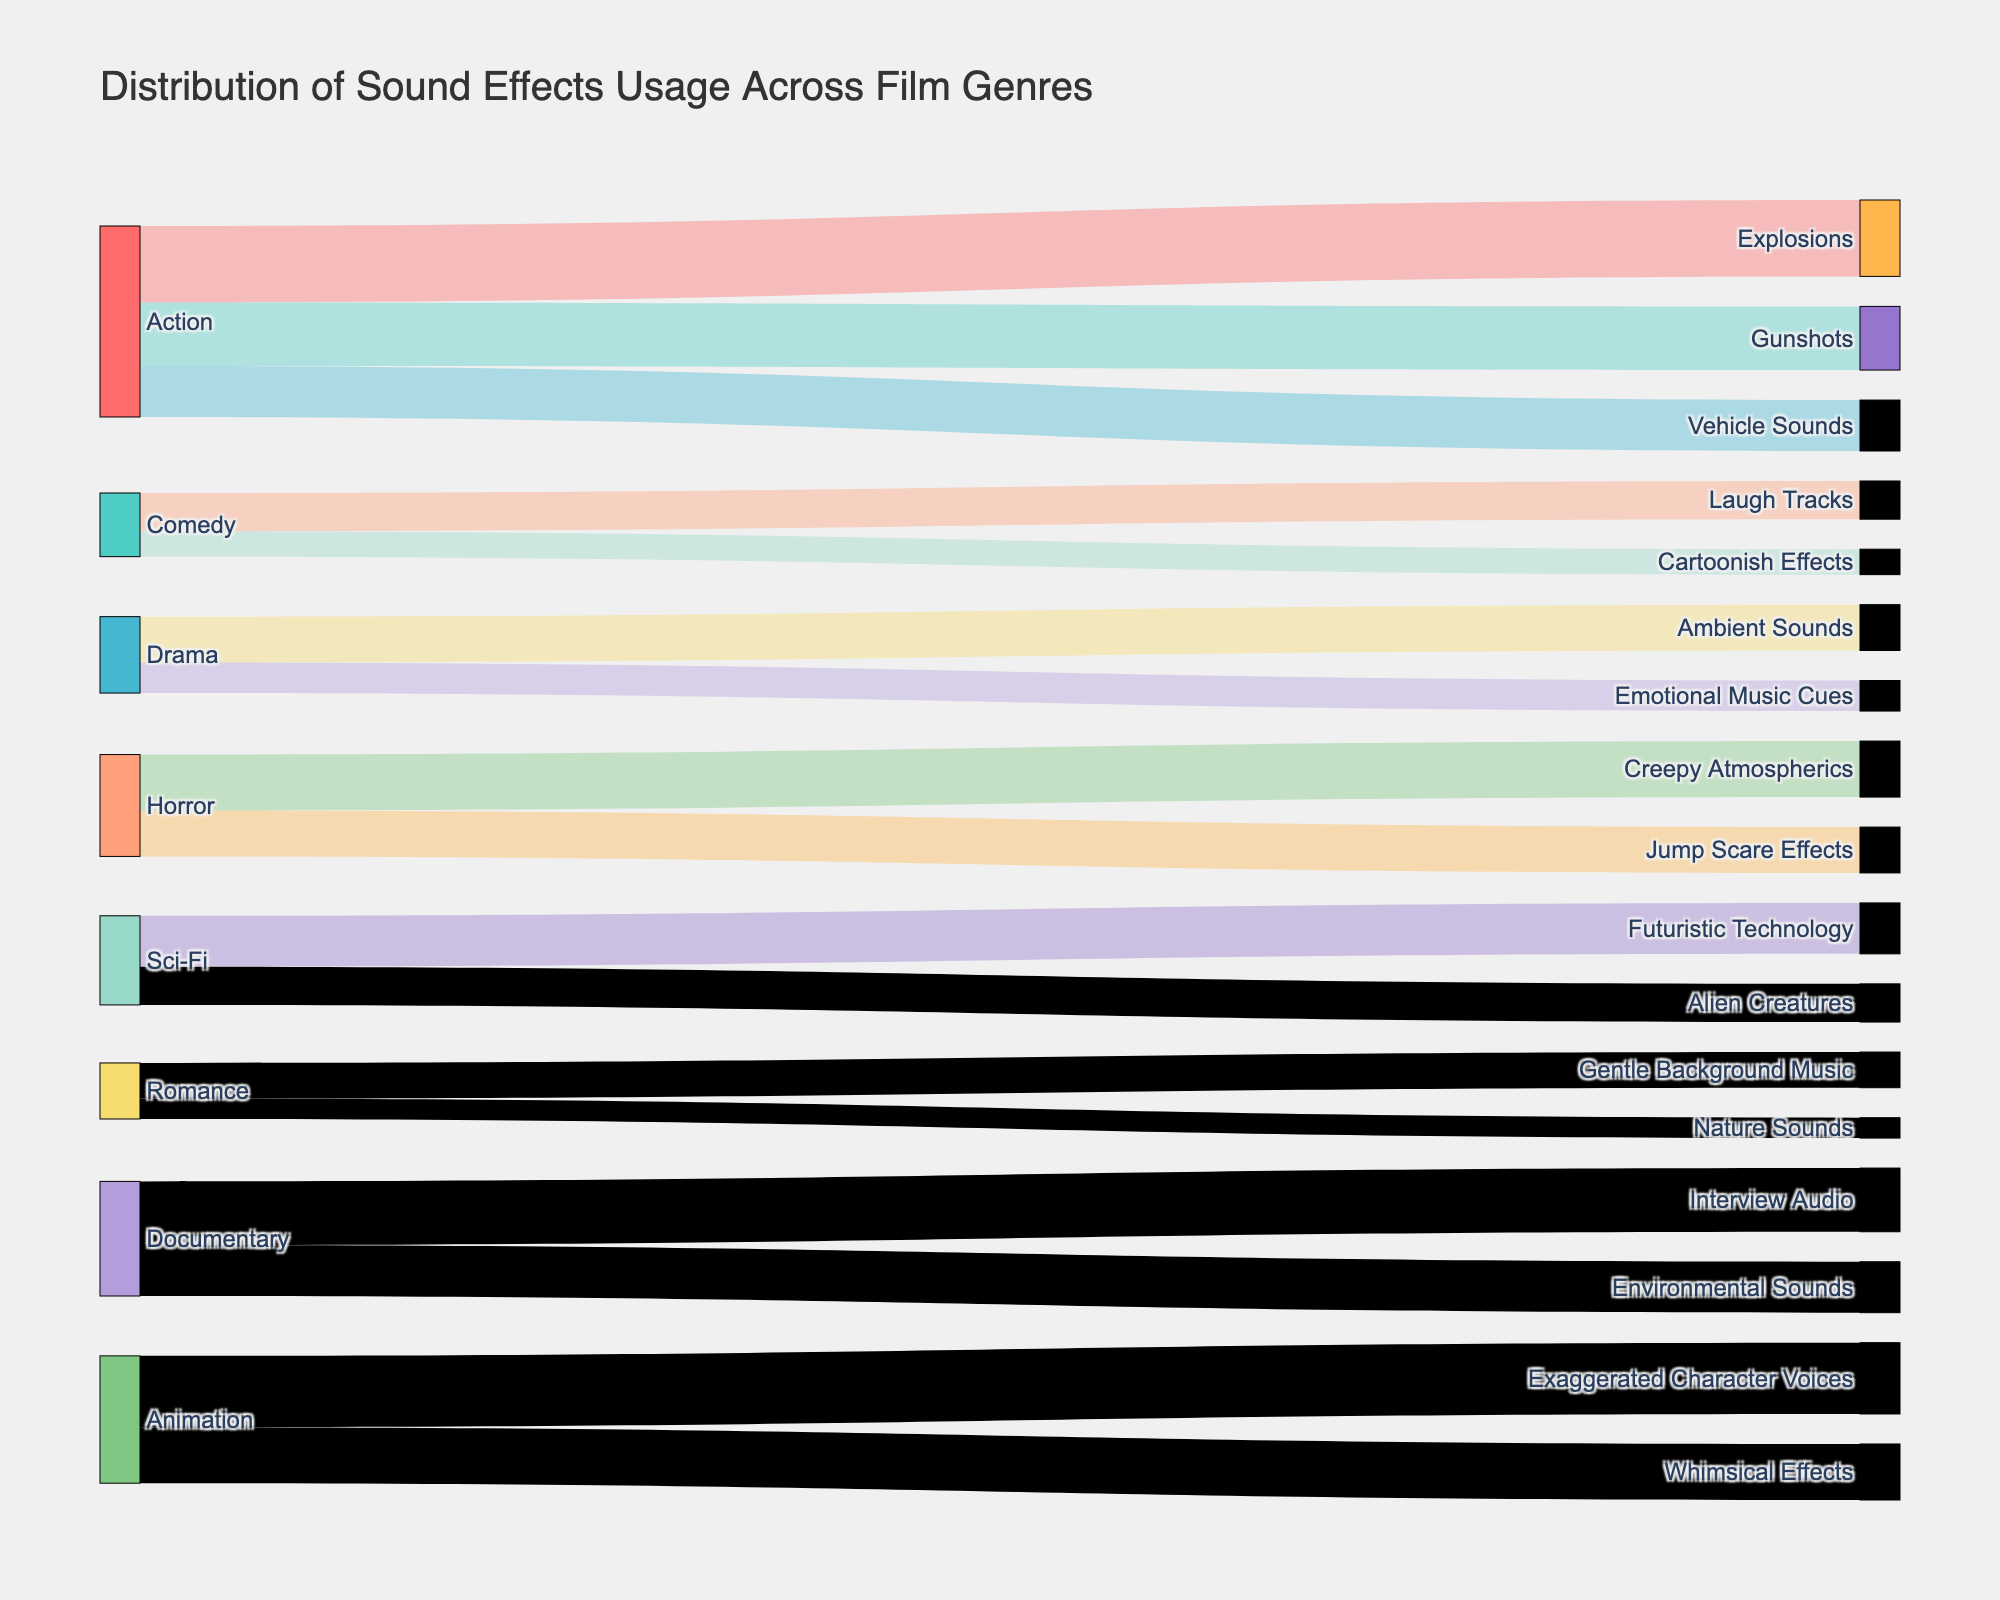Which genre uses the most sound effect types? By observing the distribution of sound effects, Animation has two main types of sound effects with high values: Exaggerated Character Voices and Whimsical Effects totaling 50, which is higher than other genres.
Answer: Animation What sound effect is most commonly used in Action films? In the Action genre, the sound effects are Explosions, Gunshots, and Vehicle Sounds with Explosions having the largest value (30). It is the most commonly used sound effect.
Answer: Explosions How many total sound effect usages are there for the Romance genre? Summing up the values for Gentle Background Music (14) and Nature Sounds (8) gives the total sound effects for Romance as 14 + 8 = 22.
Answer: 22 Which genre has the least number of sound effect usage displayed? By comparing the values, Comedy’s Cartoonish Effects has the smallest value (10) compared to all other values across genres.
Answer: Comedy Which genres use Environmental Sounds? Environmental Sounds is used in the Documentary genre with a value of 20.
Answer: Documentary What is the total usage value for sound effects in the Horror genre? Adding the values for Creepy Atmospherics (22) and Jump Scare Effects (18) gives 22 + 18 = 40.
Answer: 40 Are Jump Scare Effects or Explosions used more often, and by how much? Jump Scare Effects are used 18 times, and Explosions are used 30 times. The difference is 30 - 18 = 12.
Answer: Explosions, 12 Which genre has more sound effects usage: Sci-Fi or Drama, and by how much? Summing the values for Sci-Fi gives 20 (Futuristic Technology) + 15 (Alien Creatures) = 35, and for Drama, it’s 18 (Ambient Sounds) + 12 (Emotional Music Cues) = 30. The difference is 35 - 30 = 5.
Answer: Sci-Fi, 5 Which sound effect appears in more than one genre? By observing the targets, Environmental Sounds appears in Action and Documentary.
Answer: Environmental Sounds What is the least used sound effect in the dataset? The least used sound effect is Cartoonish Effects in Comedy with a value of 10.
Answer: Cartoonish Effects 